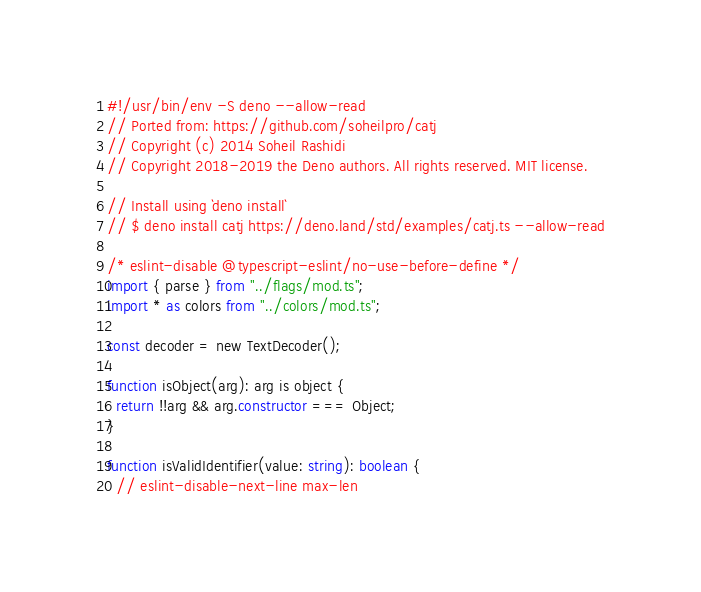Convert code to text. <code><loc_0><loc_0><loc_500><loc_500><_TypeScript_>#!/usr/bin/env -S deno --allow-read
// Ported from: https://github.com/soheilpro/catj
// Copyright (c) 2014 Soheil Rashidi
// Copyright 2018-2019 the Deno authors. All rights reserved. MIT license.

// Install using `deno install`
// $ deno install catj https://deno.land/std/examples/catj.ts --allow-read

/* eslint-disable @typescript-eslint/no-use-before-define */
import { parse } from "../flags/mod.ts";
import * as colors from "../colors/mod.ts";

const decoder = new TextDecoder();

function isObject(arg): arg is object {
  return !!arg && arg.constructor === Object;
}

function isValidIdentifier(value: string): boolean {
  // eslint-disable-next-line max-len</code> 